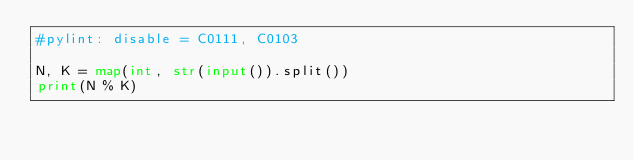Convert code to text. <code><loc_0><loc_0><loc_500><loc_500><_Python_>#pylint: disable = C0111, C0103

N, K = map(int, str(input()).split())
print(N % K)
</code> 